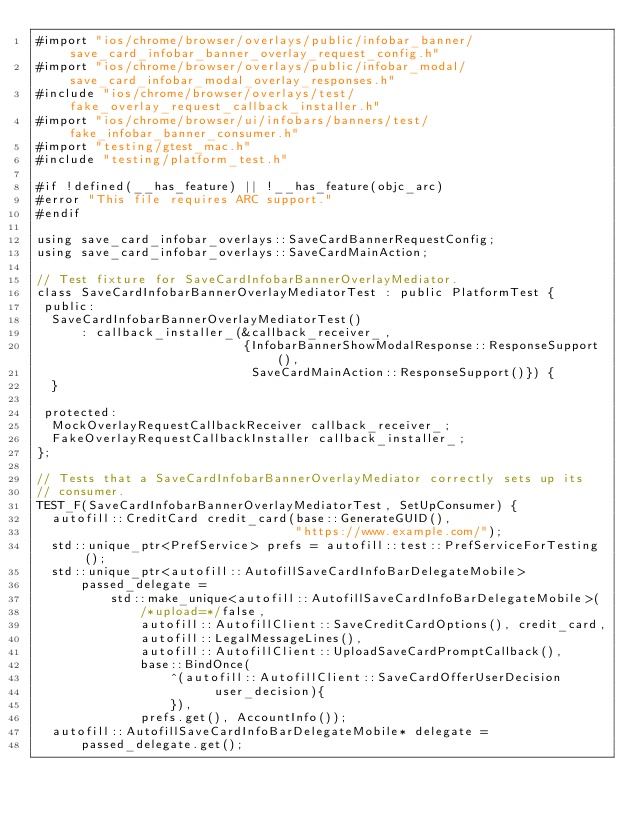Convert code to text. <code><loc_0><loc_0><loc_500><loc_500><_ObjectiveC_>#import "ios/chrome/browser/overlays/public/infobar_banner/save_card_infobar_banner_overlay_request_config.h"
#import "ios/chrome/browser/overlays/public/infobar_modal/save_card_infobar_modal_overlay_responses.h"
#include "ios/chrome/browser/overlays/test/fake_overlay_request_callback_installer.h"
#import "ios/chrome/browser/ui/infobars/banners/test/fake_infobar_banner_consumer.h"
#import "testing/gtest_mac.h"
#include "testing/platform_test.h"

#if !defined(__has_feature) || !__has_feature(objc_arc)
#error "This file requires ARC support."
#endif

using save_card_infobar_overlays::SaveCardBannerRequestConfig;
using save_card_infobar_overlays::SaveCardMainAction;

// Test fixture for SaveCardInfobarBannerOverlayMediator.
class SaveCardInfobarBannerOverlayMediatorTest : public PlatformTest {
 public:
  SaveCardInfobarBannerOverlayMediatorTest()
      : callback_installer_(&callback_receiver_,
                            {InfobarBannerShowModalResponse::ResponseSupport(),
                             SaveCardMainAction::ResponseSupport()}) {
  }

 protected:
  MockOverlayRequestCallbackReceiver callback_receiver_;
  FakeOverlayRequestCallbackInstaller callback_installer_;
};

// Tests that a SaveCardInfobarBannerOverlayMediator correctly sets up its
// consumer.
TEST_F(SaveCardInfobarBannerOverlayMediatorTest, SetUpConsumer) {
  autofill::CreditCard credit_card(base::GenerateGUID(),
                                   "https://www.example.com/");
  std::unique_ptr<PrefService> prefs = autofill::test::PrefServiceForTesting();
  std::unique_ptr<autofill::AutofillSaveCardInfoBarDelegateMobile>
      passed_delegate =
          std::make_unique<autofill::AutofillSaveCardInfoBarDelegateMobile>(
              /*upload=*/false,
              autofill::AutofillClient::SaveCreditCardOptions(), credit_card,
              autofill::LegalMessageLines(),
              autofill::AutofillClient::UploadSaveCardPromptCallback(),
              base::BindOnce(
                  ^(autofill::AutofillClient::SaveCardOfferUserDecision
                        user_decision){
                  }),
              prefs.get(), AccountInfo());
  autofill::AutofillSaveCardInfoBarDelegateMobile* delegate =
      passed_delegate.get();</code> 